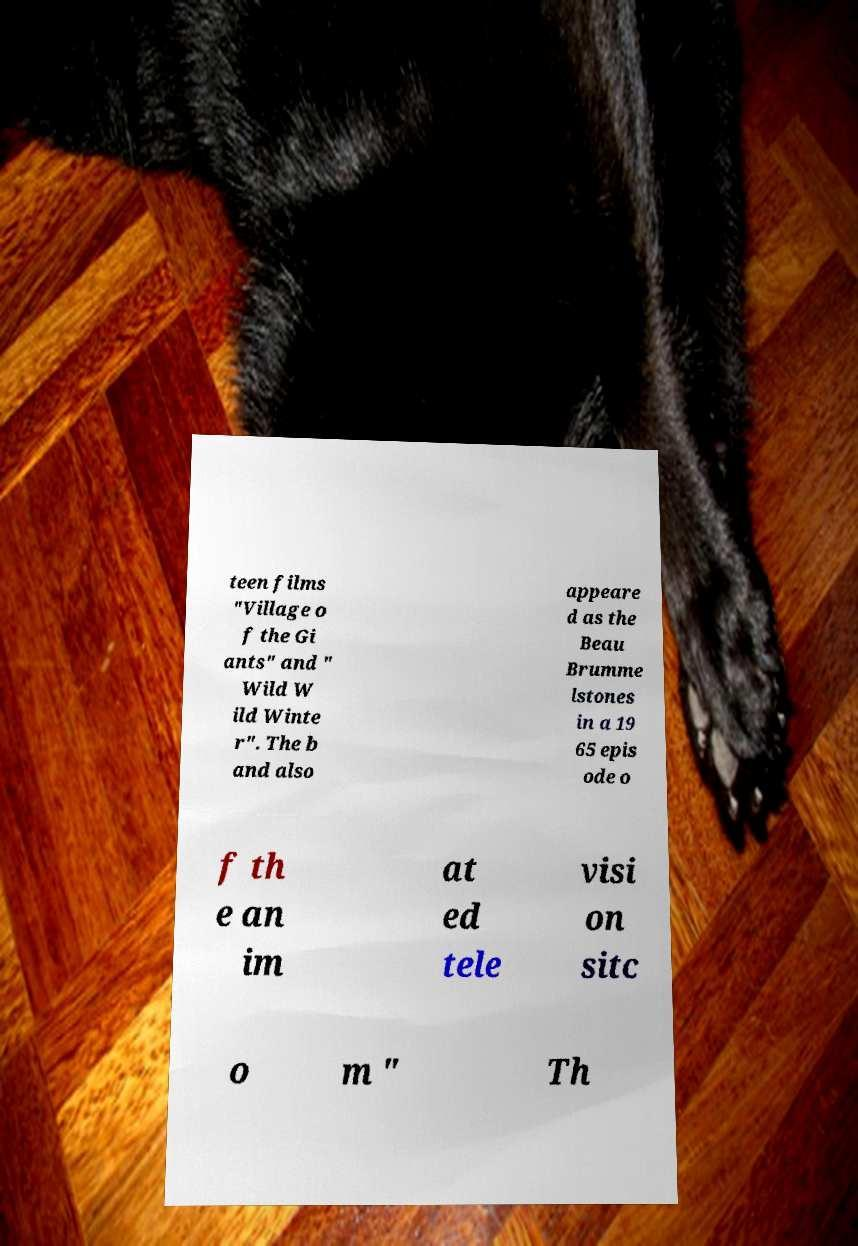For documentation purposes, I need the text within this image transcribed. Could you provide that? teen films "Village o f the Gi ants" and " Wild W ild Winte r". The b and also appeare d as the Beau Brumme lstones in a 19 65 epis ode o f th e an im at ed tele visi on sitc o m " Th 